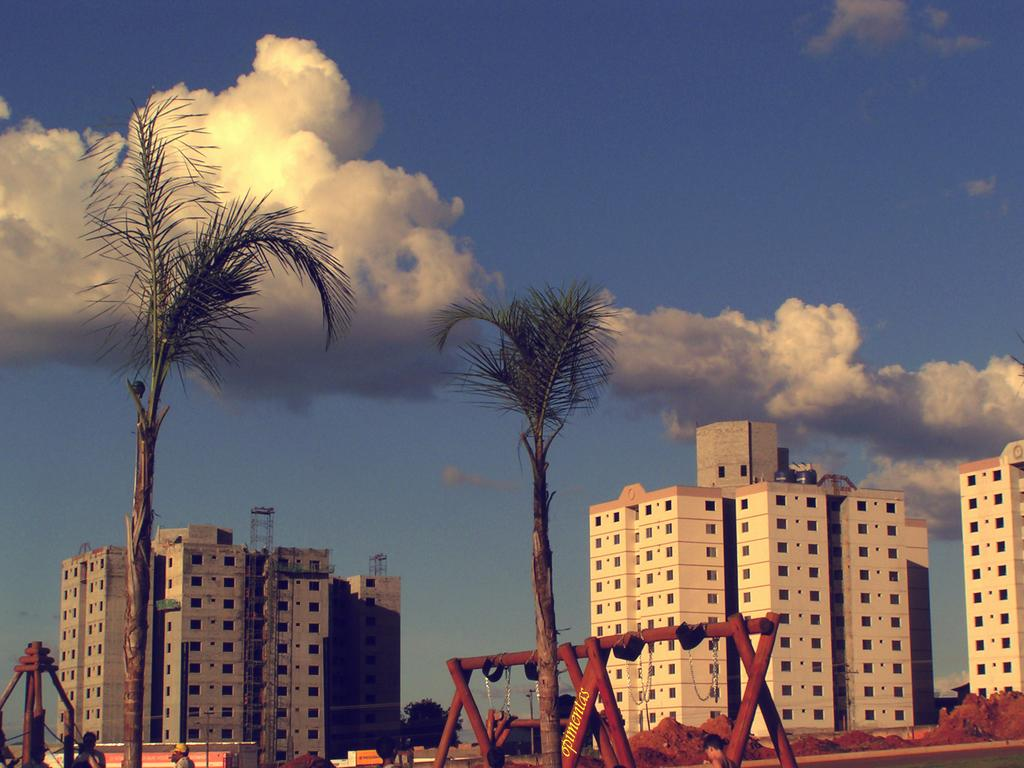What type of structures can be seen in the image? There are buildings in the image. What type of vegetation is present in the image? There are trees in the image. How many pigs can be seen running through the field in the image? There are no pigs or fields present in the image; it features buildings and trees. 